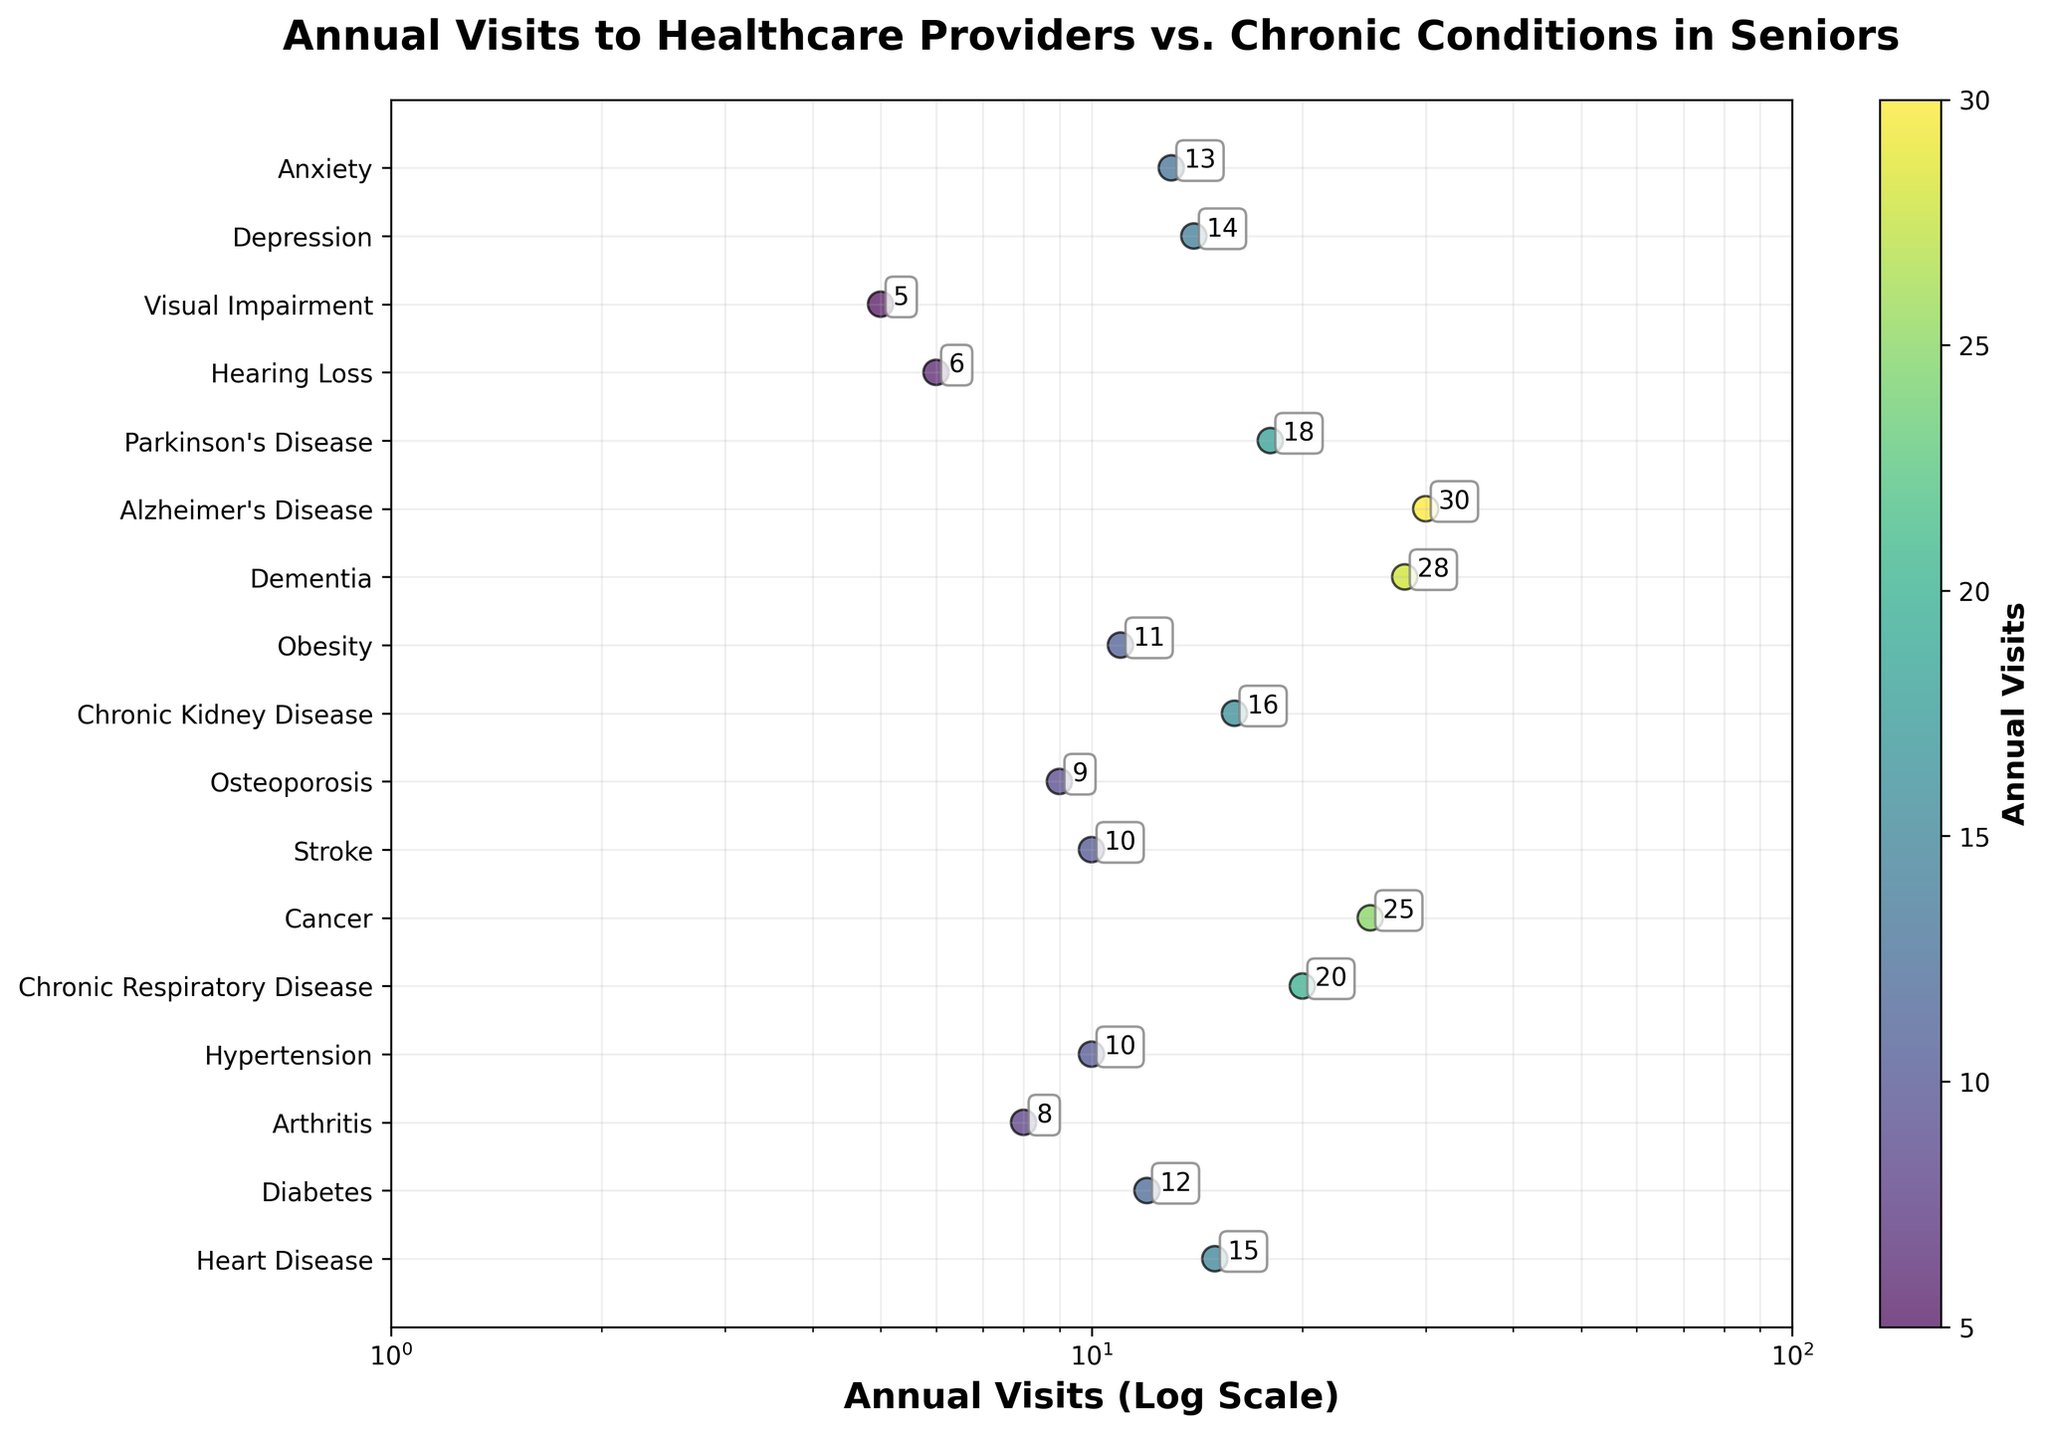What is the title of the figure? The title is displayed at the top center of the figure. It is in a larger and bolder font, making it easily noticeable.
Answer: Annual Visits to Healthcare Providers vs. Chronic Conditions in Seniors How many chronic conditions are plotted in the figure? The y-axis has tick marks that correspond to each chronic condition. By counting these tick marks, we can determine the total number.
Answer: 17 What is the range of the x-axis, and what type of scale is used? The x-axis range can be observed from the axis limits. Additionally, the scale type is indicated near the axis.
Answer: 1 to 100, log scale Which chronic condition corresponds to the highest number of annual visits? The data points are scattered vertically according to chronic conditions. The highest value can be identified by finding the rightmost point.
Answer: Alzheimer's Disease Which condition shows the least number of annual visits? The leftmost data point on the plot will correspond to the minimum number of annual visits.
Answer: Visual Impairment What is the difference in annual visits between Dementia and Hypertension? The number of annual visits for each condition is annotated next to the points. By subtracting values, we find the difference. Dementia has 28 visits, and Hypertension has 10. 28 - 10 = 18.
Answer: 18 How many conditions have more than 15 annual visits? Identify the data points on the plot that are to the right of the x-axis value of 15. Count these points to get the number of conditions.
Answer: 5 What is the average number of annual visits for Obesity and Parkinson's Disease? The figure shows Obesity with 11 visits and Parkinson's Disease with 18 visits. The average is (11 + 18) / 2 = 14.5.
Answer: 14.5 Which chronic conditions fall within the range of 5 to 10 annual visits? Look for data points between the x-axis values of 5 and 10. Then, refer to the y-tick labels to identify the conditions.
Answer: Arthritis, Hypertension, Stroke, Osteoporosis, Hearing Loss, Visual Impairment In what way does the log scale of the x-axis affect the interpretation of the data points? On a log scale, equal distances represent multiplicative changes rather than additive. This means smaller values are spread out, and larger values are compressed. It helps to view data spanning multiple orders of magnitude more clearly.
Answer: Provides better visualization for wide-ranging data 